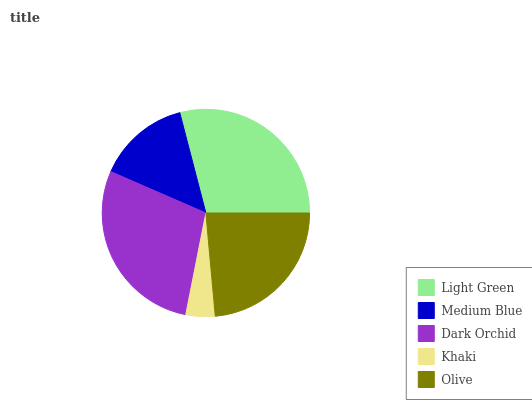Is Khaki the minimum?
Answer yes or no. Yes. Is Light Green the maximum?
Answer yes or no. Yes. Is Medium Blue the minimum?
Answer yes or no. No. Is Medium Blue the maximum?
Answer yes or no. No. Is Light Green greater than Medium Blue?
Answer yes or no. Yes. Is Medium Blue less than Light Green?
Answer yes or no. Yes. Is Medium Blue greater than Light Green?
Answer yes or no. No. Is Light Green less than Medium Blue?
Answer yes or no. No. Is Olive the high median?
Answer yes or no. Yes. Is Olive the low median?
Answer yes or no. Yes. Is Dark Orchid the high median?
Answer yes or no. No. Is Light Green the low median?
Answer yes or no. No. 